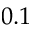<formula> <loc_0><loc_0><loc_500><loc_500>0 . 1</formula> 